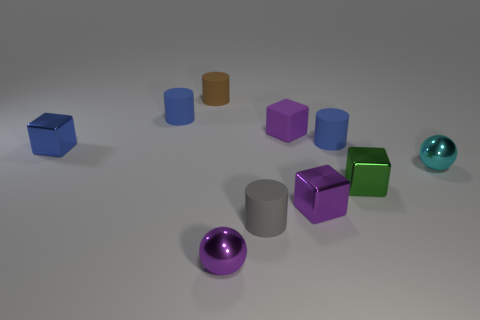What shape is the green object that is the same size as the cyan shiny ball?
Give a very brief answer. Cube. Are there the same number of purple objects that are behind the small green cube and large brown rubber cubes?
Offer a terse response. No. There is a tiny purple thing in front of the cylinder that is in front of the blue rubber thing in front of the small purple matte cube; what is its material?
Your response must be concise. Metal. What shape is the blue thing that is the same material as the cyan sphere?
Provide a succinct answer. Cube. Are there any other things that have the same color as the rubber cube?
Offer a very short reply. Yes. What number of rubber objects are right of the small object in front of the small matte thing that is in front of the cyan metallic ball?
Offer a terse response. 3. What number of gray things are matte cylinders or large matte blocks?
Provide a short and direct response. 1. There is a purple rubber object; is it the same size as the blue cylinder that is left of the purple shiny block?
Your response must be concise. Yes. What is the material of the tiny brown object that is the same shape as the gray matte object?
Provide a succinct answer. Rubber. How many other objects are the same size as the brown thing?
Offer a terse response. 9. 